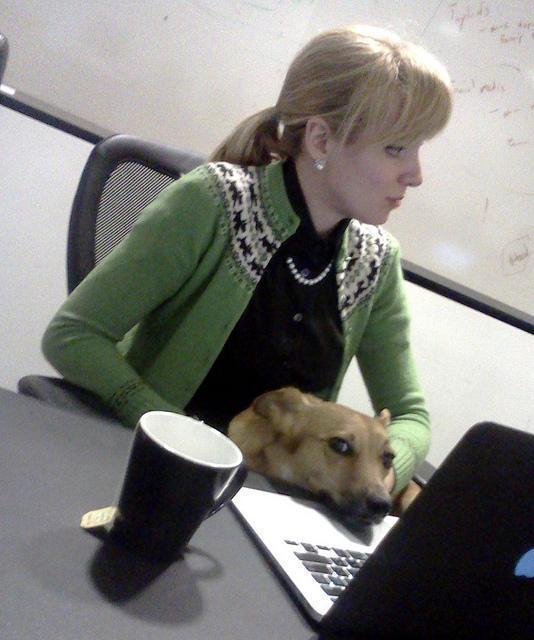How many people are there?
Give a very brief answer. 1. How many giraffes are shown?
Give a very brief answer. 0. 